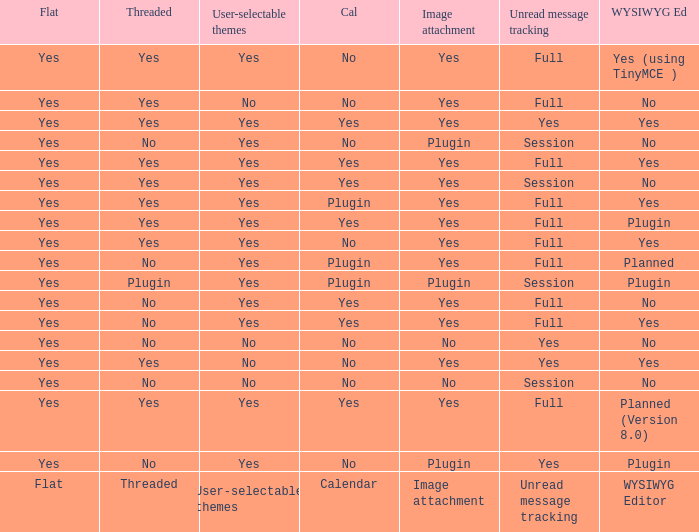Which Calendar has WYSIWYG Editor of yes and an Unread message tracking of yes? Yes, No. 